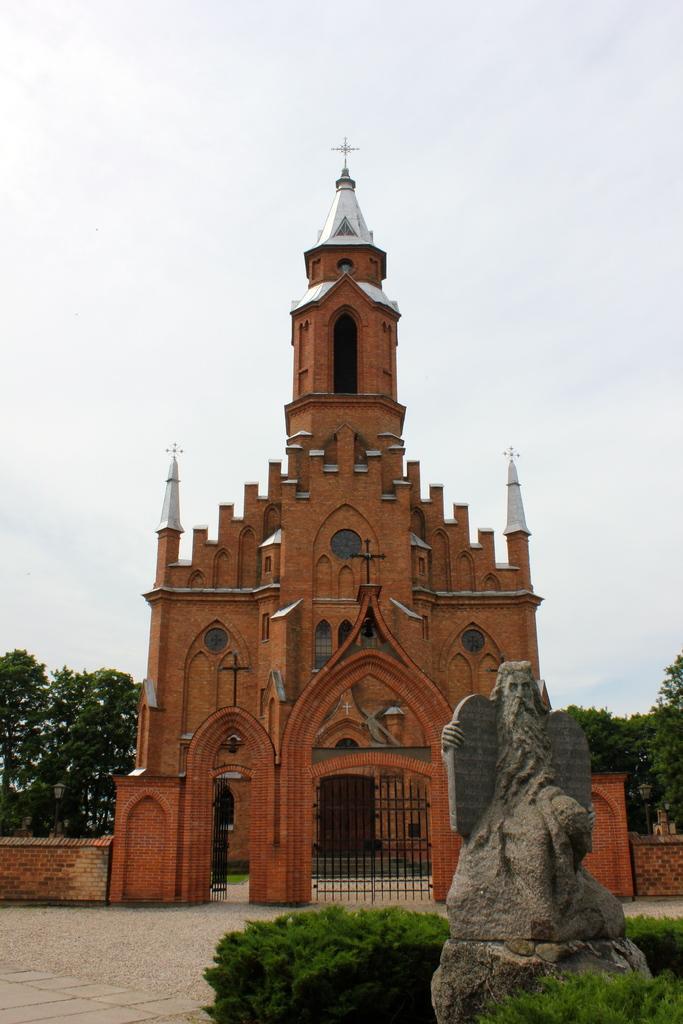Please provide a concise description of this image. In this image, in the middle there is a building. At the bottom there are plants, statue, floor. In the background there are trees, sky, clouds. 